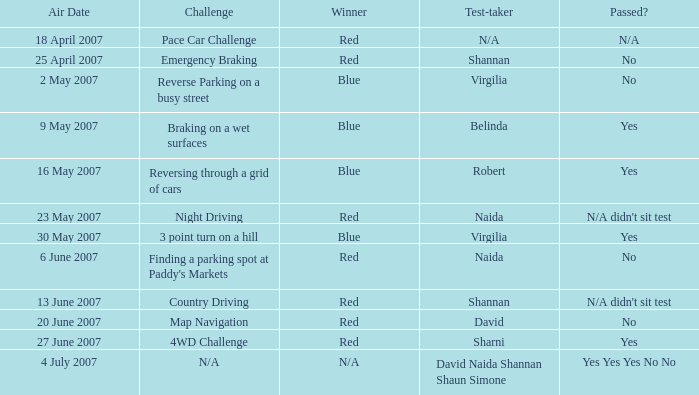What is the effect of passing the countryside driving examination? N/A didn't sit test. 